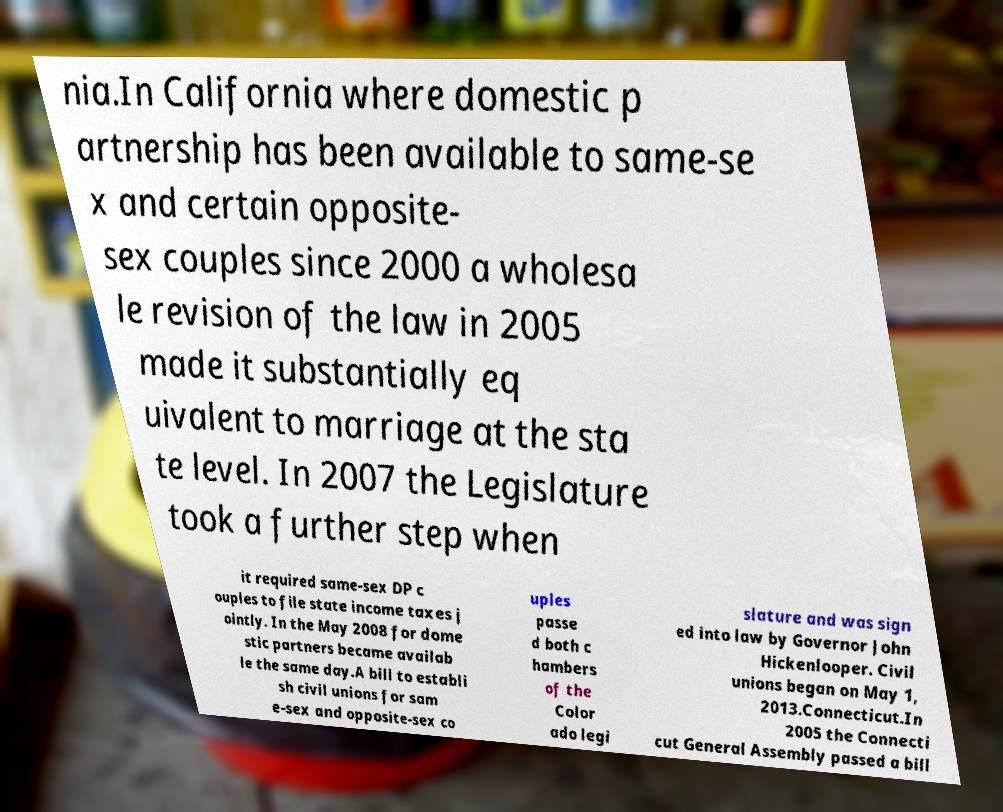What messages or text are displayed in this image? I need them in a readable, typed format. nia.In California where domestic p artnership has been available to same-se x and certain opposite- sex couples since 2000 a wholesa le revision of the law in 2005 made it substantially eq uivalent to marriage at the sta te level. In 2007 the Legislature took a further step when it required same-sex DP c ouples to file state income taxes j ointly. In the May 2008 for dome stic partners became availab le the same day.A bill to establi sh civil unions for sam e-sex and opposite-sex co uples passe d both c hambers of the Color ado legi slature and was sign ed into law by Governor John Hickenlooper. Civil unions began on May 1, 2013.Connecticut.In 2005 the Connecti cut General Assembly passed a bill 